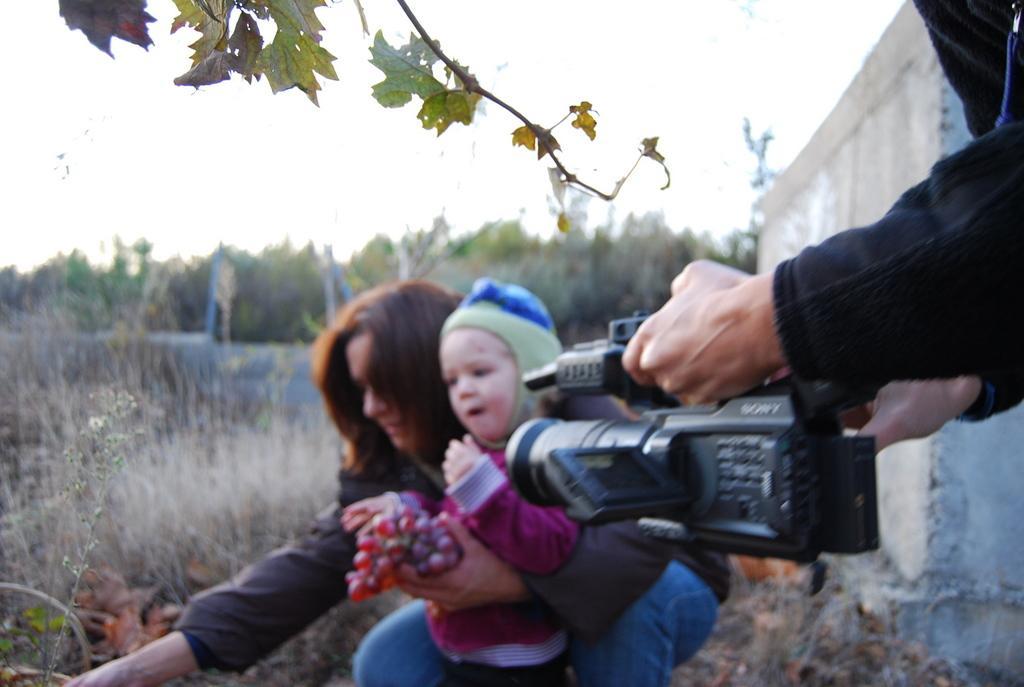Describe this image in one or two sentences. The image clicked outside the city. There are three persons in the image. Lady , a kid and a man. The man is holding the camera, the woman holding the kid and grapes in her hands. In the background there are many trees and grass. 